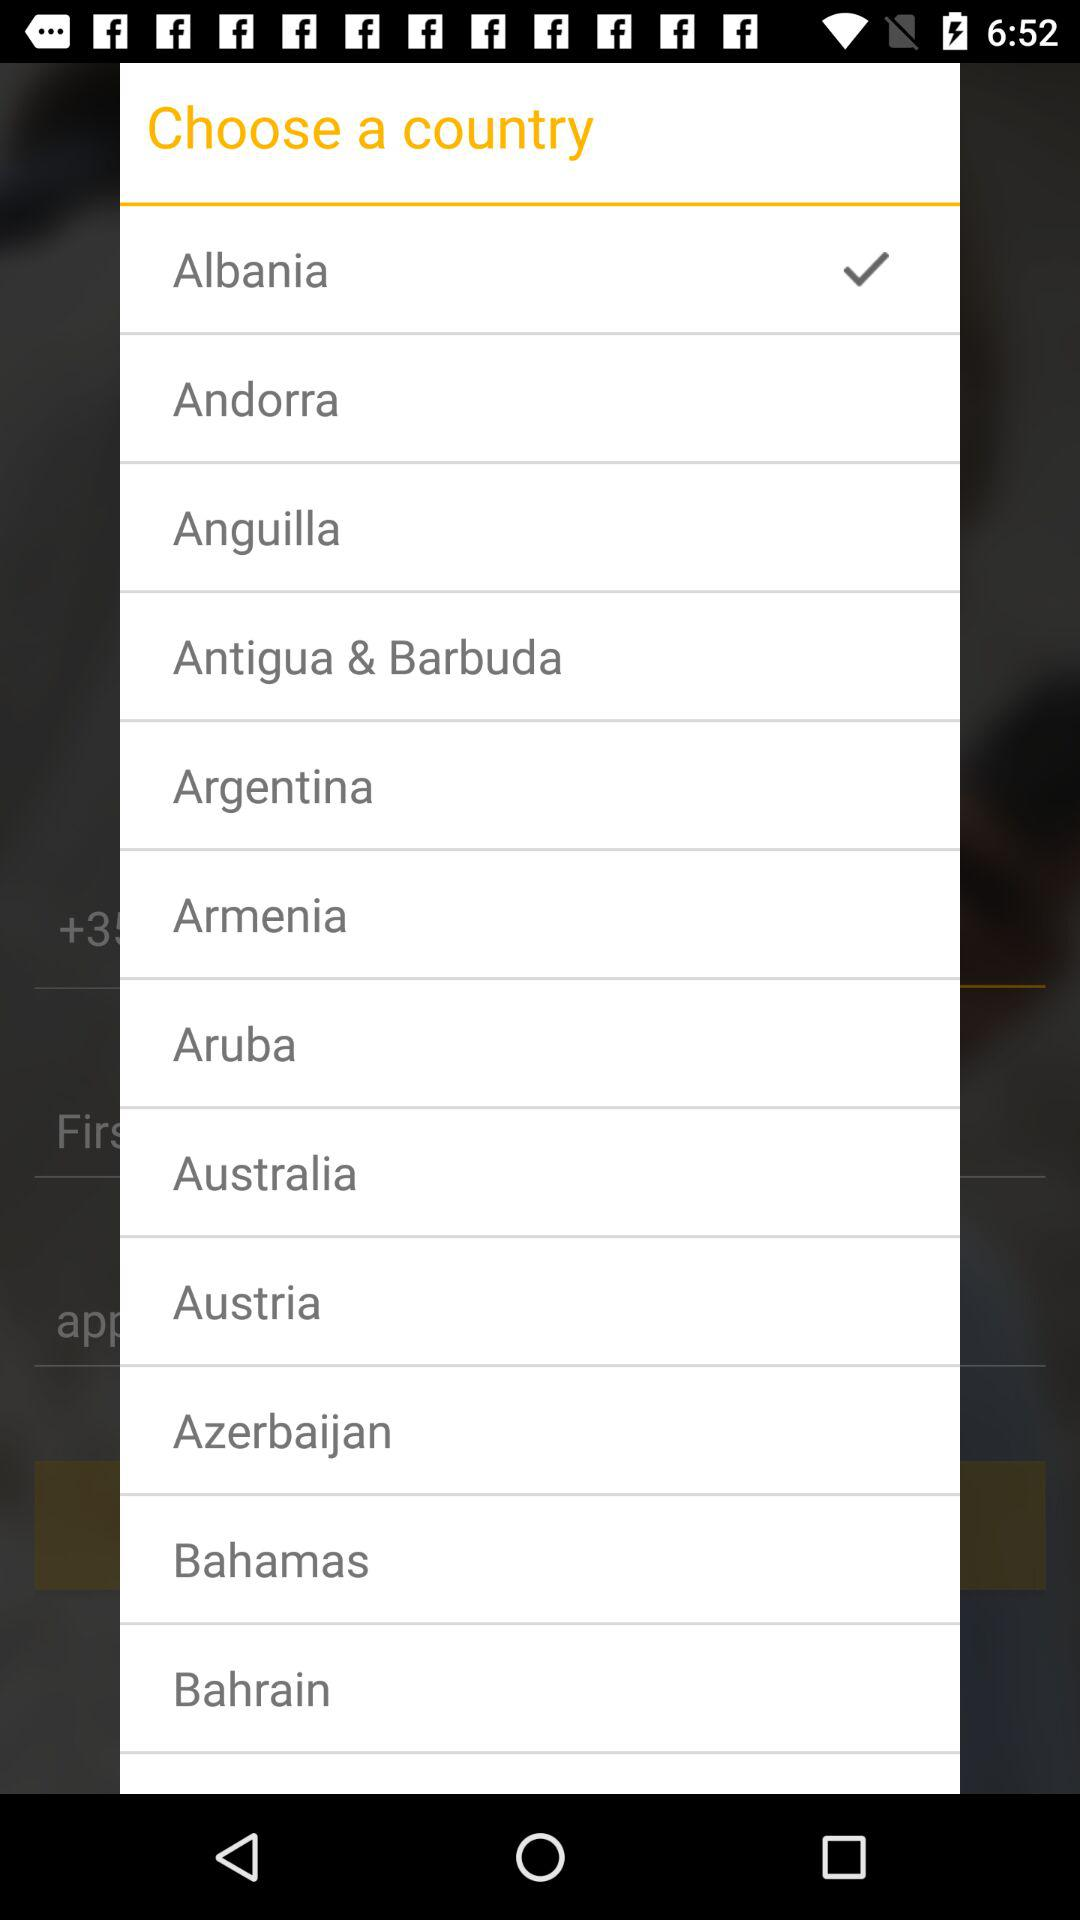How many countries can be chosen?
When the provided information is insufficient, respond with <no answer>. <no answer> 